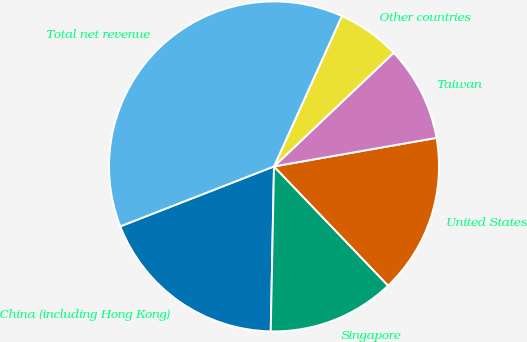<chart> <loc_0><loc_0><loc_500><loc_500><pie_chart><fcel>China (including Hong Kong)<fcel>Singapore<fcel>United States<fcel>Taiwan<fcel>Other countries<fcel>Total net revenue<nl><fcel>18.77%<fcel>12.47%<fcel>15.62%<fcel>9.32%<fcel>6.17%<fcel>37.67%<nl></chart> 